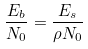<formula> <loc_0><loc_0><loc_500><loc_500>\frac { E _ { b } } { N _ { 0 } } = \frac { E _ { s } } { \rho N _ { 0 } }</formula> 